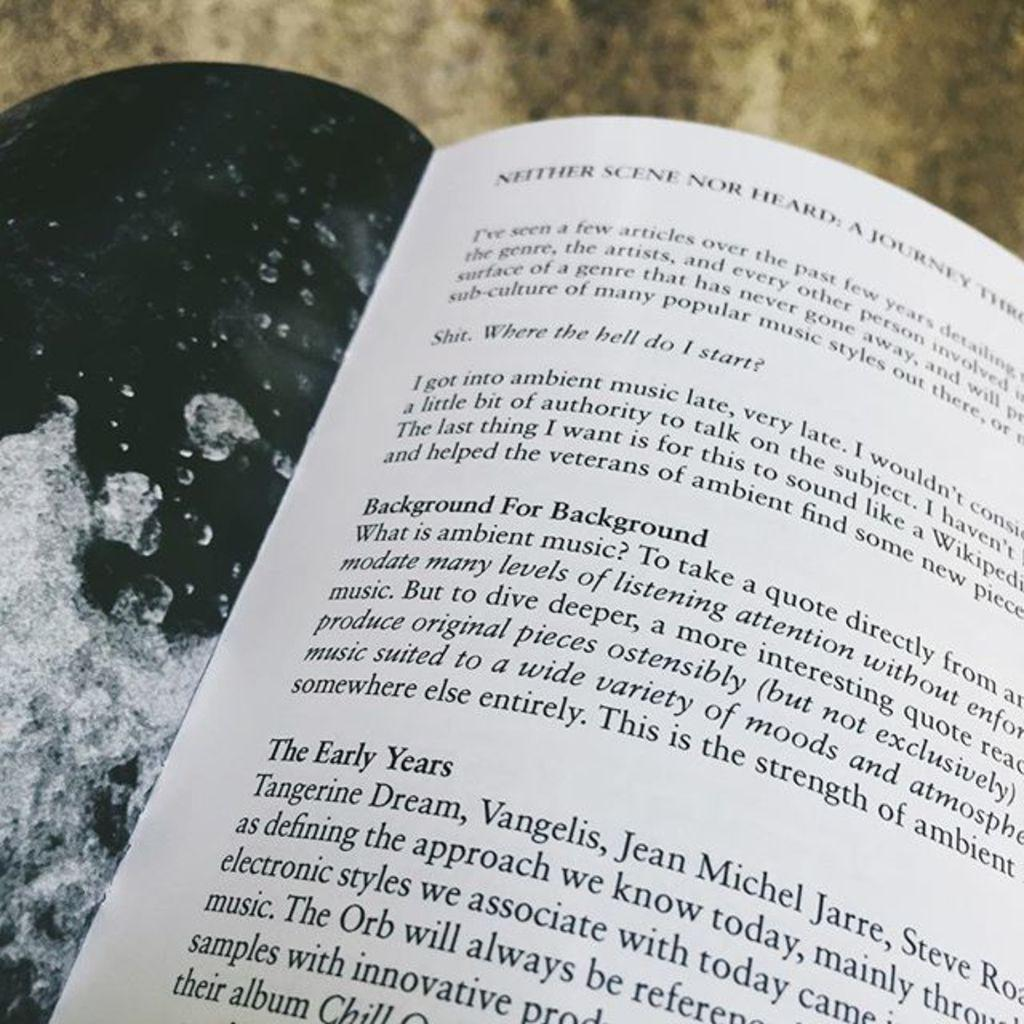<image>
Present a compact description of the photo's key features. A book is open to a page that has a section called "background for background." 